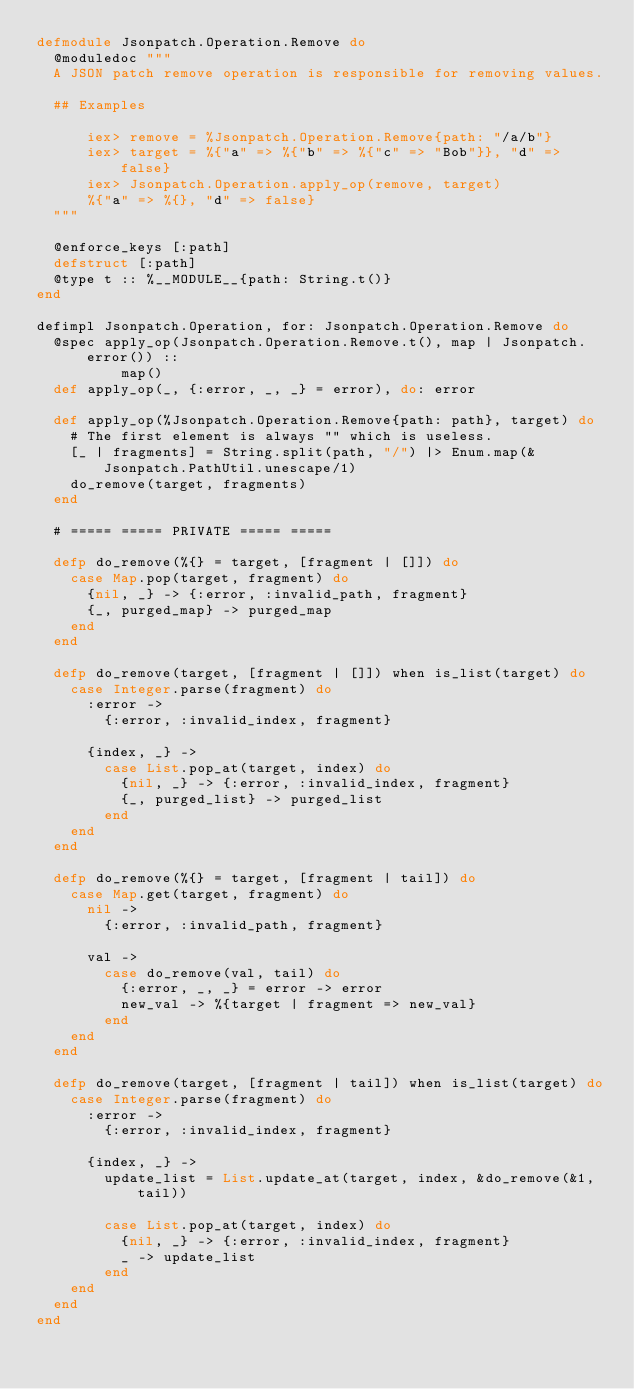<code> <loc_0><loc_0><loc_500><loc_500><_Elixir_>defmodule Jsonpatch.Operation.Remove do
  @moduledoc """
  A JSON patch remove operation is responsible for removing values.

  ## Examples

      iex> remove = %Jsonpatch.Operation.Remove{path: "/a/b"}
      iex> target = %{"a" => %{"b" => %{"c" => "Bob"}}, "d" => false}
      iex> Jsonpatch.Operation.apply_op(remove, target)
      %{"a" => %{}, "d" => false}
  """

  @enforce_keys [:path]
  defstruct [:path]
  @type t :: %__MODULE__{path: String.t()}
end

defimpl Jsonpatch.Operation, for: Jsonpatch.Operation.Remove do
  @spec apply_op(Jsonpatch.Operation.Remove.t(), map | Jsonpatch.error()) ::
          map()
  def apply_op(_, {:error, _, _} = error), do: error

  def apply_op(%Jsonpatch.Operation.Remove{path: path}, target) do
    # The first element is always "" which is useless.
    [_ | fragments] = String.split(path, "/") |> Enum.map(&Jsonpatch.PathUtil.unescape/1)
    do_remove(target, fragments)
  end

  # ===== ===== PRIVATE ===== =====

  defp do_remove(%{} = target, [fragment | []]) do
    case Map.pop(target, fragment) do
      {nil, _} -> {:error, :invalid_path, fragment}
      {_, purged_map} -> purged_map
    end
  end

  defp do_remove(target, [fragment | []]) when is_list(target) do
    case Integer.parse(fragment) do
      :error ->
        {:error, :invalid_index, fragment}

      {index, _} ->
        case List.pop_at(target, index) do
          {nil, _} -> {:error, :invalid_index, fragment}
          {_, purged_list} -> purged_list
        end
    end
  end

  defp do_remove(%{} = target, [fragment | tail]) do
    case Map.get(target, fragment) do
      nil ->
        {:error, :invalid_path, fragment}

      val ->
        case do_remove(val, tail) do
          {:error, _, _} = error -> error
          new_val -> %{target | fragment => new_val}
        end
    end
  end

  defp do_remove(target, [fragment | tail]) when is_list(target) do
    case Integer.parse(fragment) do
      :error ->
        {:error, :invalid_index, fragment}

      {index, _} ->
        update_list = List.update_at(target, index, &do_remove(&1, tail))

        case List.pop_at(target, index) do
          {nil, _} -> {:error, :invalid_index, fragment}
          _ -> update_list
        end
    end
  end
end
</code> 